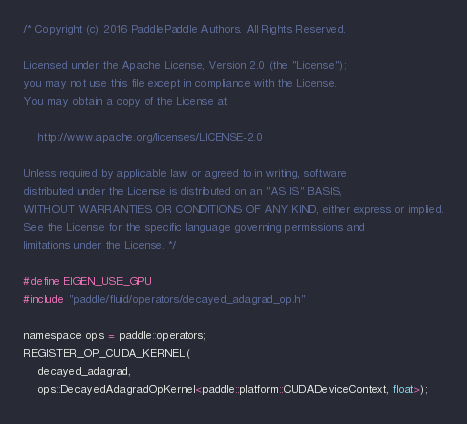Convert code to text. <code><loc_0><loc_0><loc_500><loc_500><_Cuda_>/* Copyright (c) 2016 PaddlePaddle Authors. All Rights Reserved.

Licensed under the Apache License, Version 2.0 (the "License");
you may not use this file except in compliance with the License.
You may obtain a copy of the License at

    http://www.apache.org/licenses/LICENSE-2.0

Unless required by applicable law or agreed to in writing, software
distributed under the License is distributed on an "AS IS" BASIS,
WITHOUT WARRANTIES OR CONDITIONS OF ANY KIND, either express or implied.
See the License for the specific language governing permissions and
limitations under the License. */

#define EIGEN_USE_GPU
#include "paddle/fluid/operators/decayed_adagrad_op.h"

namespace ops = paddle::operators;
REGISTER_OP_CUDA_KERNEL(
    decayed_adagrad,
    ops::DecayedAdagradOpKernel<paddle::platform::CUDADeviceContext, float>);
</code> 